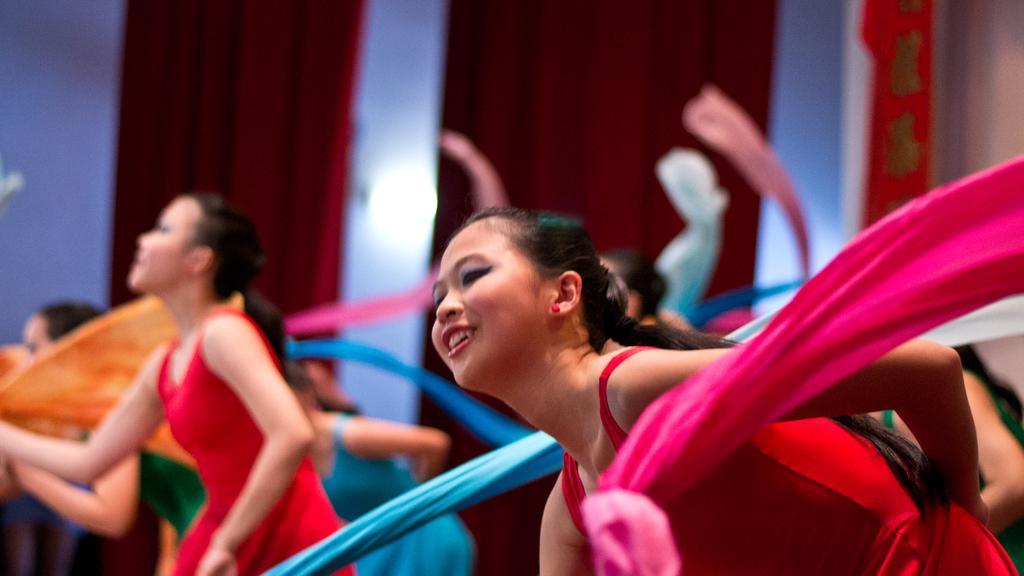Please provide a concise description of this image. In the center of the image we can see a few people are performing and they are holding some colorful clothes. And they are smiling, which we can see on their faces. In the background there is a wall, curtains, lights and a few other objects. 